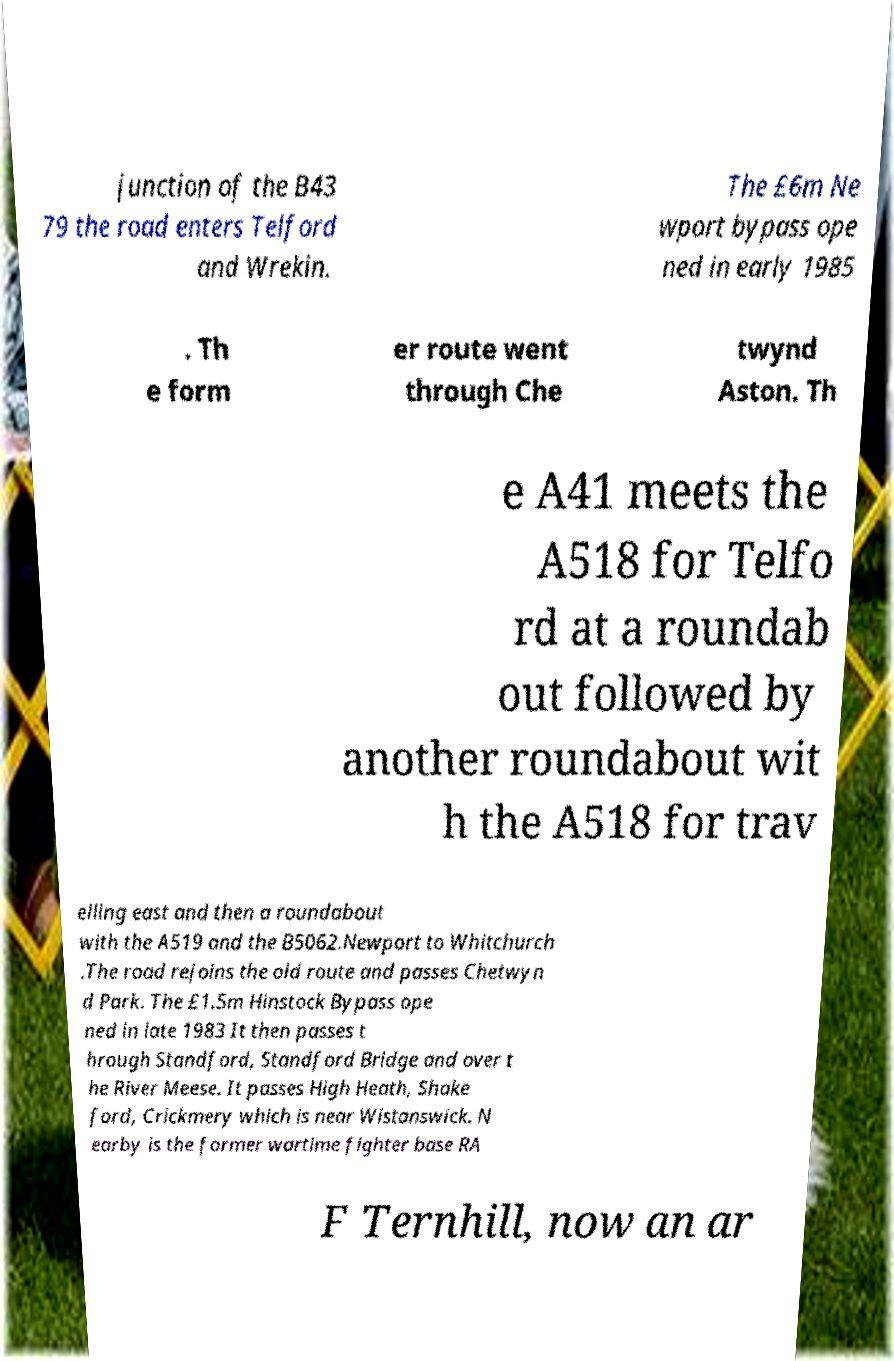Please read and relay the text visible in this image. What does it say? junction of the B43 79 the road enters Telford and Wrekin. The £6m Ne wport bypass ope ned in early 1985 . Th e form er route went through Che twynd Aston. Th e A41 meets the A518 for Telfo rd at a roundab out followed by another roundabout wit h the A518 for trav elling east and then a roundabout with the A519 and the B5062.Newport to Whitchurch .The road rejoins the old route and passes Chetwyn d Park. The £1.5m Hinstock Bypass ope ned in late 1983 It then passes t hrough Standford, Standford Bridge and over t he River Meese. It passes High Heath, Shake ford, Crickmery which is near Wistanswick. N earby is the former wartime fighter base RA F Ternhill, now an ar 